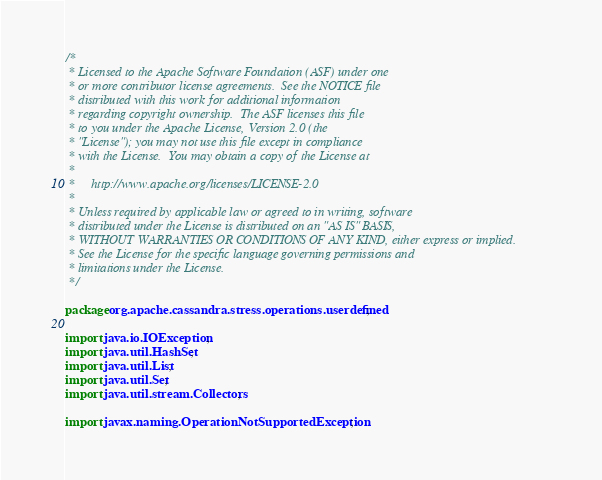<code> <loc_0><loc_0><loc_500><loc_500><_Java_>/*
 * Licensed to the Apache Software Foundation (ASF) under one
 * or more contributor license agreements.  See the NOTICE file
 * distributed with this work for additional information
 * regarding copyright ownership.  The ASF licenses this file
 * to you under the Apache License, Version 2.0 (the
 * "License"); you may not use this file except in compliance
 * with the License.  You may obtain a copy of the License at
 *
 *     http://www.apache.org/licenses/LICENSE-2.0
 *
 * Unless required by applicable law or agreed to in writing, software
 * distributed under the License is distributed on an "AS IS" BASIS,
 * WITHOUT WARRANTIES OR CONDITIONS OF ANY KIND, either express or implied.
 * See the License for the specific language governing permissions and
 * limitations under the License.
 */

package org.apache.cassandra.stress.operations.userdefined;

import java.io.IOException;
import java.util.HashSet;
import java.util.List;
import java.util.Set;
import java.util.stream.Collectors;

import javax.naming.OperationNotSupportedException;
</code> 